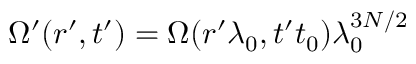Convert formula to latex. <formula><loc_0><loc_0><loc_500><loc_500>\Omega ^ { \prime } ( r ^ { \prime } , t ^ { \prime } ) = \Omega ( r ^ { \prime } \lambda _ { 0 } , t ^ { \prime } t _ { 0 } ) \lambda _ { 0 } ^ { 3 N / 2 }</formula> 